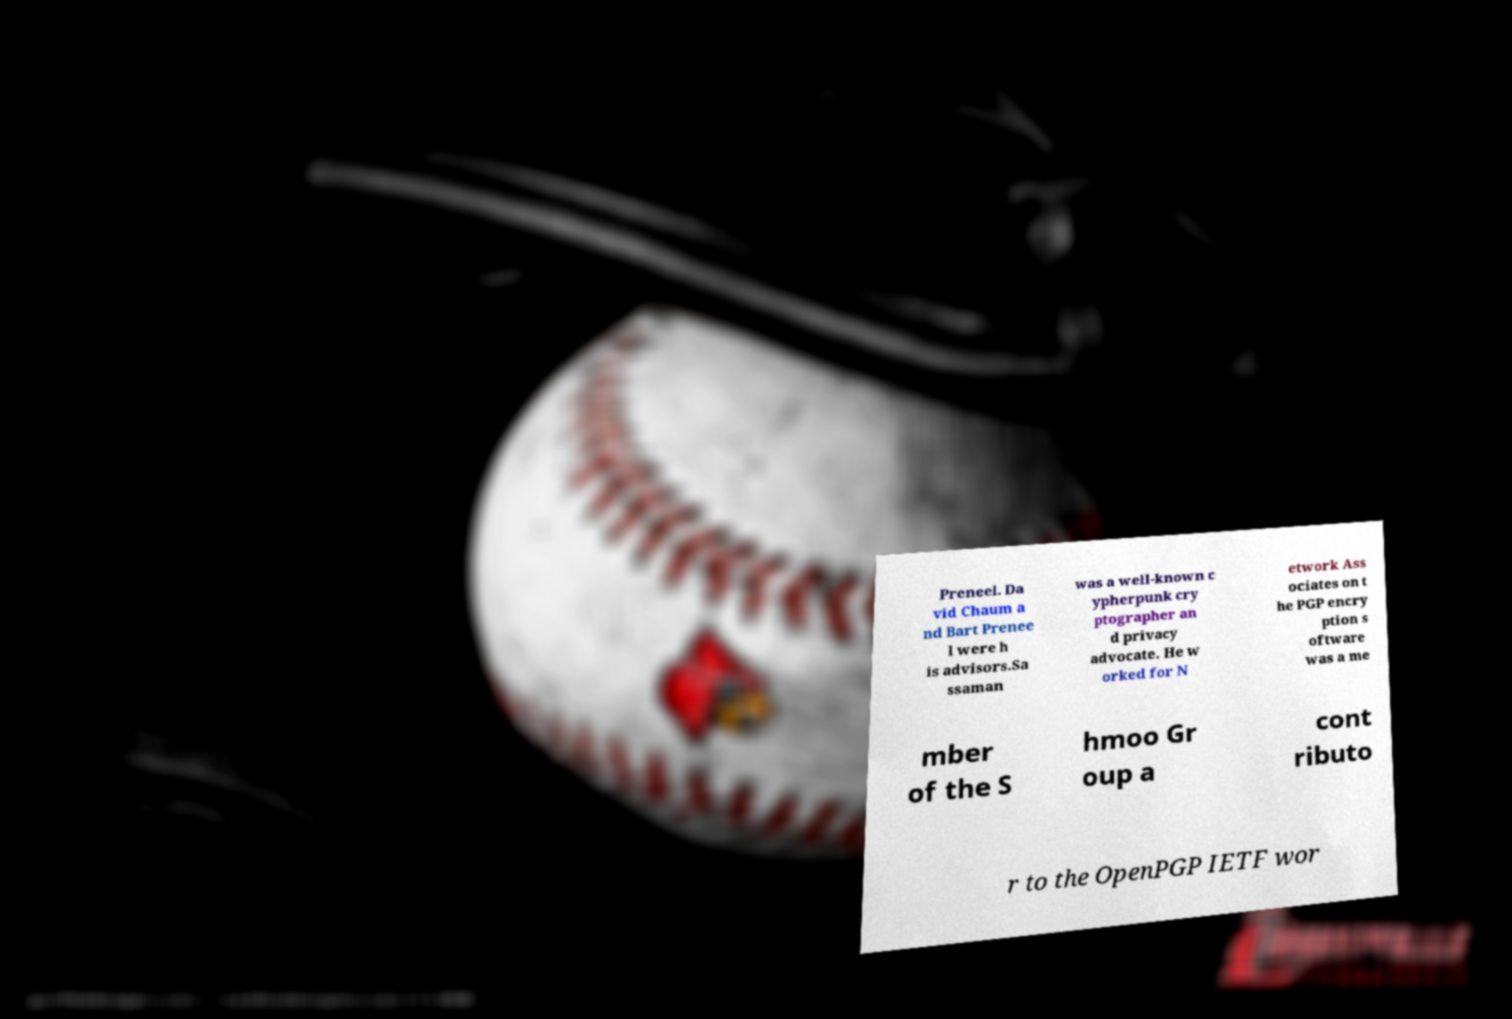Could you extract and type out the text from this image? Preneel. Da vid Chaum a nd Bart Prenee l were h is advisors.Sa ssaman was a well-known c ypherpunk cry ptographer an d privacy advocate. He w orked for N etwork Ass ociates on t he PGP encry ption s oftware was a me mber of the S hmoo Gr oup a cont ributo r to the OpenPGP IETF wor 